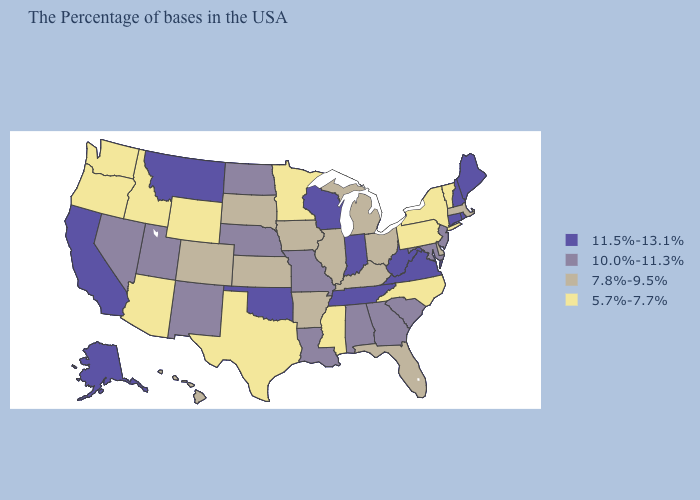Name the states that have a value in the range 11.5%-13.1%?
Keep it brief. Maine, Rhode Island, New Hampshire, Connecticut, Virginia, West Virginia, Indiana, Tennessee, Wisconsin, Oklahoma, Montana, California, Alaska. Does Maine have a higher value than Pennsylvania?
Be succinct. Yes. Does Virginia have the highest value in the South?
Answer briefly. Yes. How many symbols are there in the legend?
Write a very short answer. 4. Does Montana have the same value as Idaho?
Concise answer only. No. Does the first symbol in the legend represent the smallest category?
Quick response, please. No. Name the states that have a value in the range 10.0%-11.3%?
Concise answer only. New Jersey, Maryland, South Carolina, Georgia, Alabama, Louisiana, Missouri, Nebraska, North Dakota, New Mexico, Utah, Nevada. Among the states that border Oklahoma , which have the highest value?
Quick response, please. Missouri, New Mexico. How many symbols are there in the legend?
Short answer required. 4. What is the lowest value in states that border Kentucky?
Quick response, please. 7.8%-9.5%. What is the value of Montana?
Concise answer only. 11.5%-13.1%. Name the states that have a value in the range 11.5%-13.1%?
Quick response, please. Maine, Rhode Island, New Hampshire, Connecticut, Virginia, West Virginia, Indiana, Tennessee, Wisconsin, Oklahoma, Montana, California, Alaska. Name the states that have a value in the range 10.0%-11.3%?
Quick response, please. New Jersey, Maryland, South Carolina, Georgia, Alabama, Louisiana, Missouri, Nebraska, North Dakota, New Mexico, Utah, Nevada. Among the states that border Montana , does Wyoming have the lowest value?
Quick response, please. Yes. What is the highest value in states that border Vermont?
Be succinct. 11.5%-13.1%. 